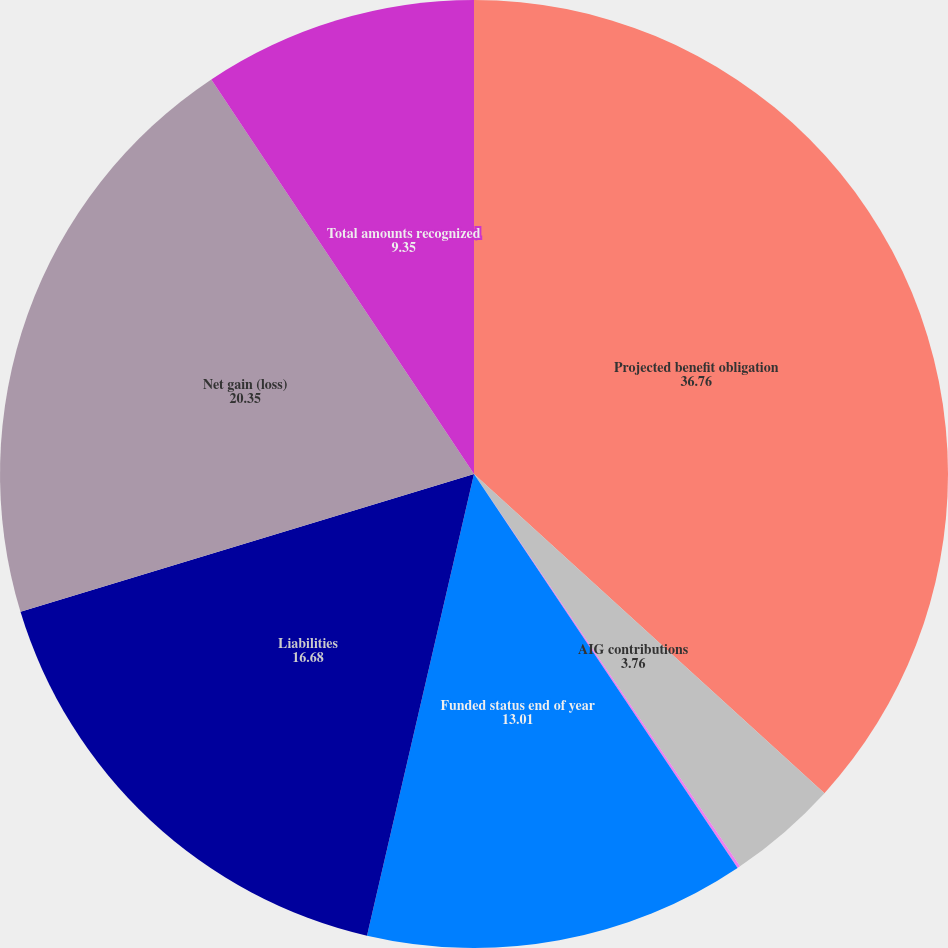Convert chart. <chart><loc_0><loc_0><loc_500><loc_500><pie_chart><fcel>Projected benefit obligation<fcel>AIG contributions<fcel>AIG assets<fcel>Funded status end of year<fcel>Liabilities<fcel>Net gain (loss)<fcel>Total amounts recognized<nl><fcel>36.76%<fcel>3.76%<fcel>0.1%<fcel>13.01%<fcel>16.68%<fcel>20.35%<fcel>9.35%<nl></chart> 